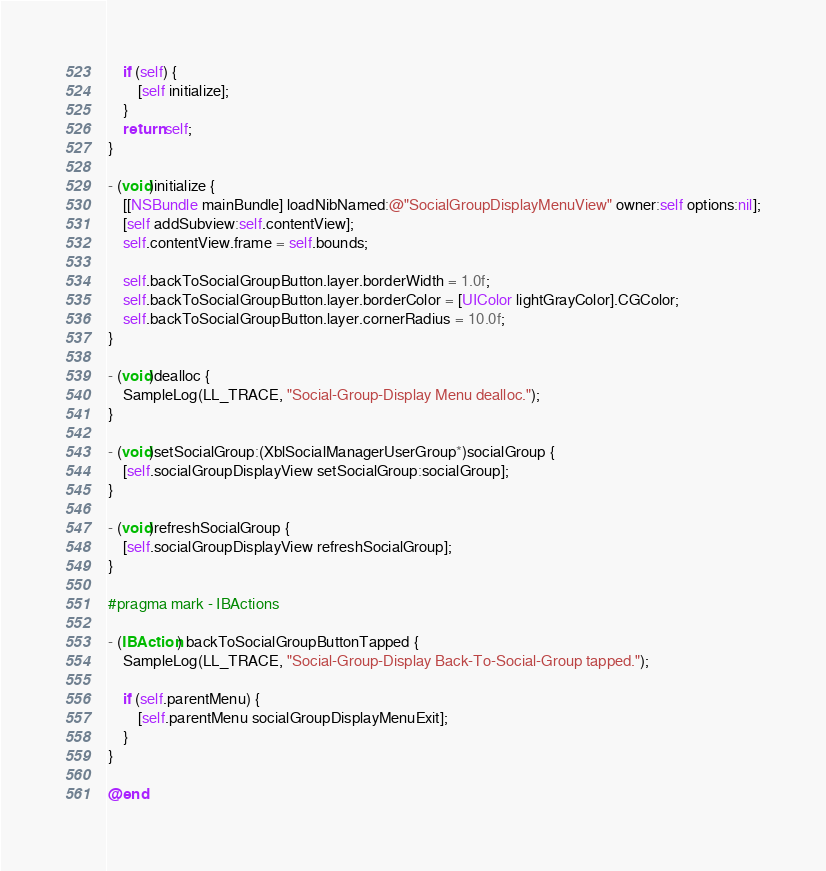Convert code to text. <code><loc_0><loc_0><loc_500><loc_500><_ObjectiveC_>    if (self) {
        [self initialize];
    }
    return self;
} 

- (void)initialize {
    [[NSBundle mainBundle] loadNibNamed:@"SocialGroupDisplayMenuView" owner:self options:nil];
    [self addSubview:self.contentView];
    self.contentView.frame = self.bounds;
    
    self.backToSocialGroupButton.layer.borderWidth = 1.0f;
    self.backToSocialGroupButton.layer.borderColor = [UIColor lightGrayColor].CGColor;
    self.backToSocialGroupButton.layer.cornerRadius = 10.0f;
}

- (void)dealloc {
    SampleLog(LL_TRACE, "Social-Group-Display Menu dealloc.");
}

- (void)setSocialGroup:(XblSocialManagerUserGroup*)socialGroup {
    [self.socialGroupDisplayView setSocialGroup:socialGroup];
}

- (void)refreshSocialGroup {
    [self.socialGroupDisplayView refreshSocialGroup];
}

#pragma mark - IBActions

- (IBAction) backToSocialGroupButtonTapped {
    SampleLog(LL_TRACE, "Social-Group-Display Back-To-Social-Group tapped.");
    
    if (self.parentMenu) {
        [self.parentMenu socialGroupDisplayMenuExit];
    }
}

@end
</code> 